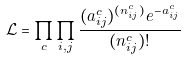<formula> <loc_0><loc_0><loc_500><loc_500>\mathcal { L } = \prod _ { c } \prod _ { i , j } \frac { ( { a ^ { c } _ { i j } } ) ^ { ( n ^ { c } _ { i j } ) } e ^ { - a ^ { c } _ { i j } } } { ( n ^ { c } _ { i j } ) ! }</formula> 